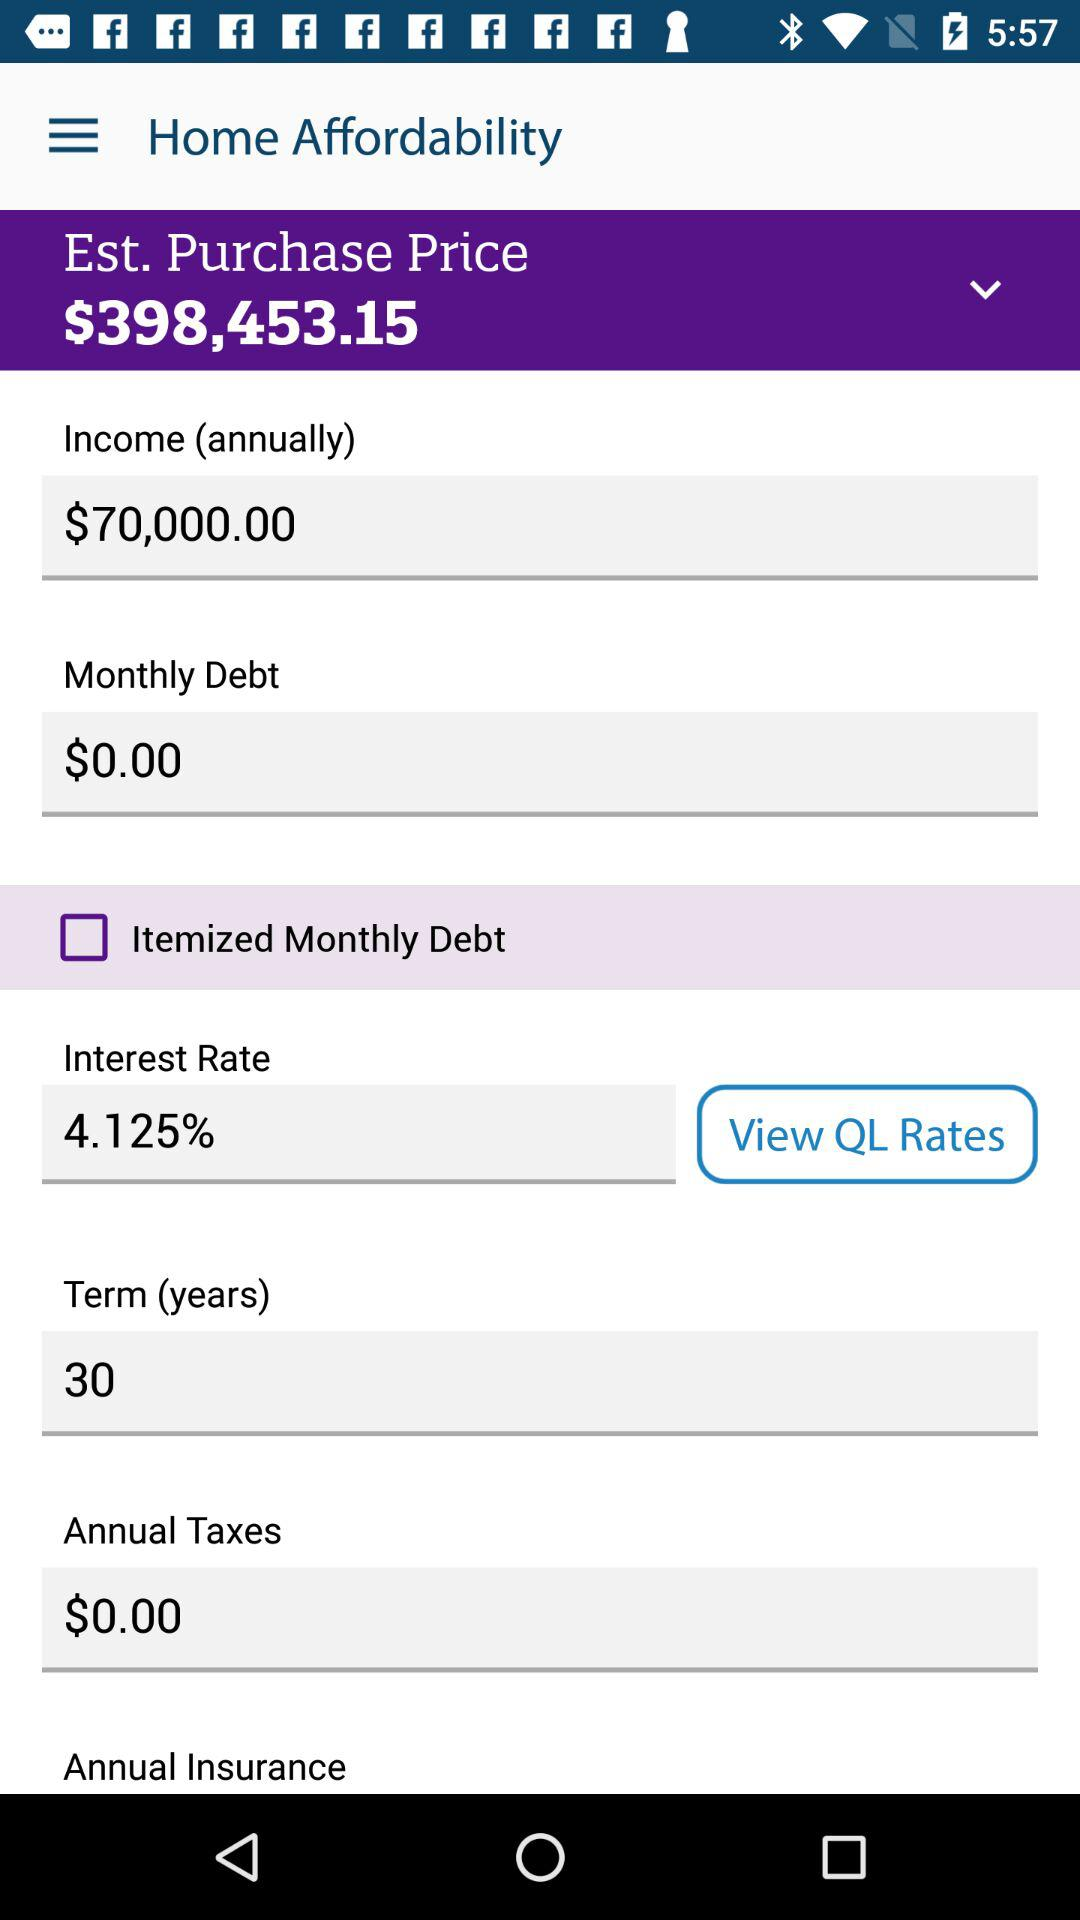How much is the monthly debt? The monthly debt is $0. 